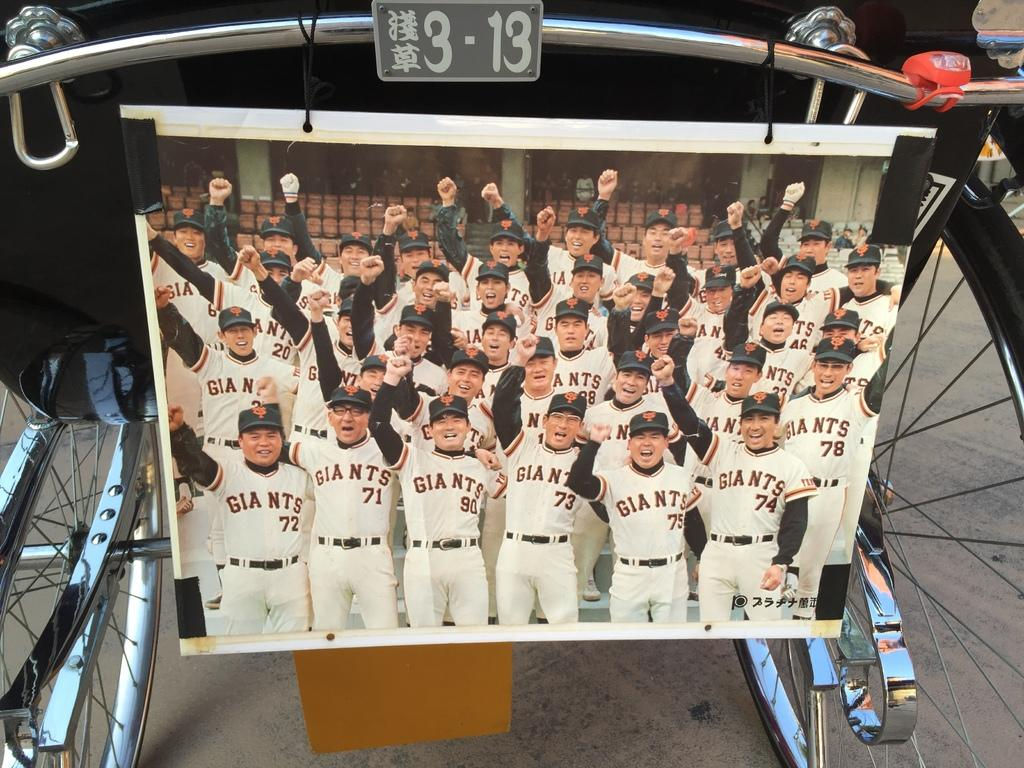<image>
Render a clear and concise summary of the photo. The Japanese Giants team poses for a group photo. 